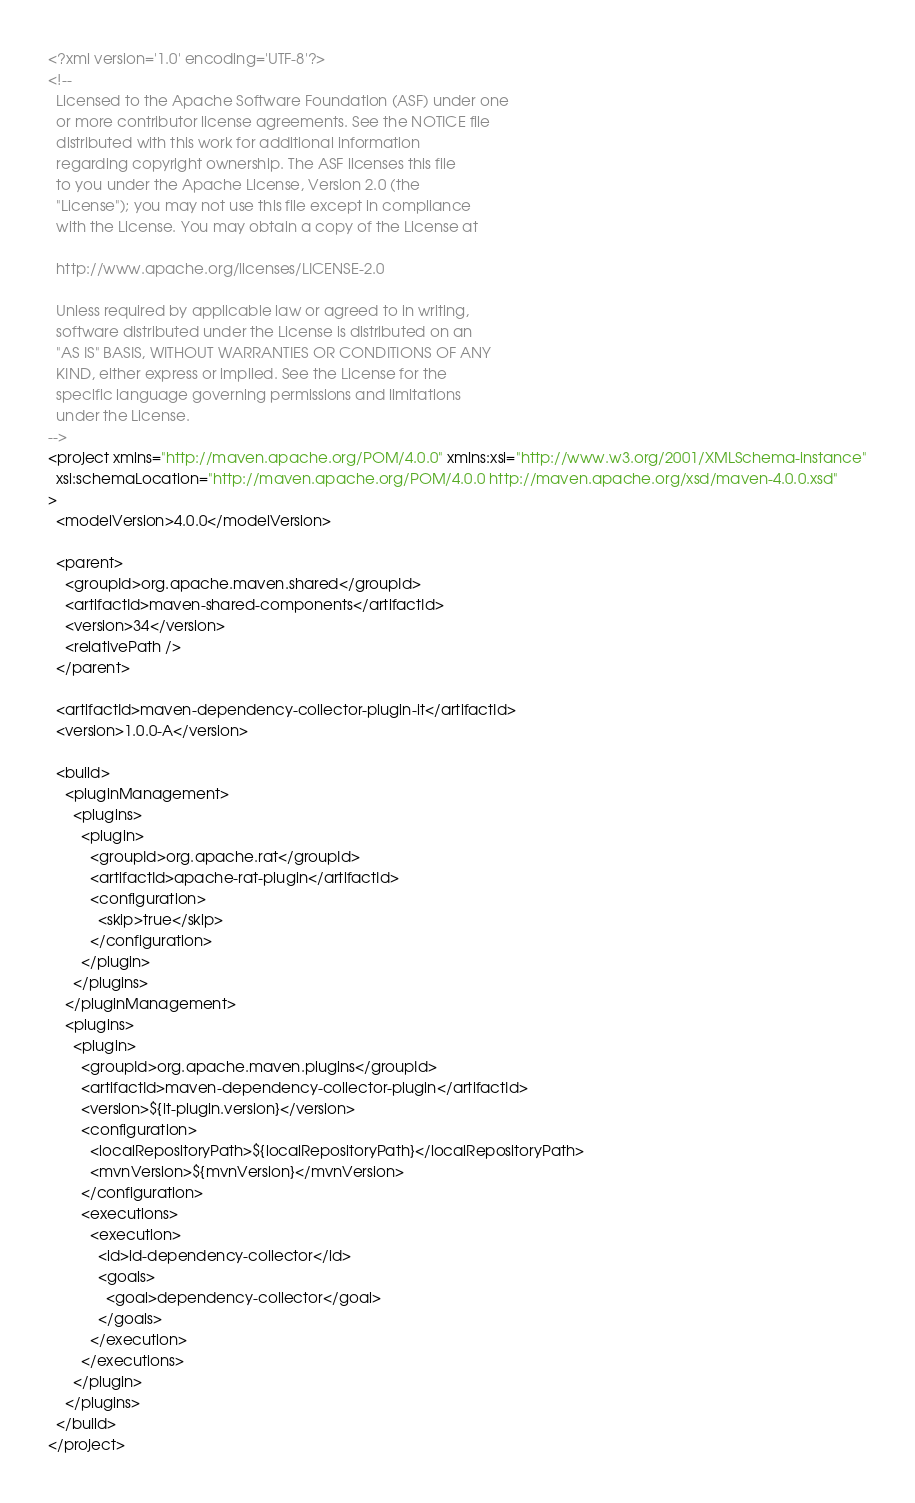Convert code to text. <code><loc_0><loc_0><loc_500><loc_500><_XML_><?xml version='1.0' encoding='UTF-8'?>
<!--
  Licensed to the Apache Software Foundation (ASF) under one
  or more contributor license agreements. See the NOTICE file
  distributed with this work for additional information
  regarding copyright ownership. The ASF licenses this file
  to you under the Apache License, Version 2.0 (the
  "License"); you may not use this file except in compliance
  with the License. You may obtain a copy of the License at

  http://www.apache.org/licenses/LICENSE-2.0

  Unless required by applicable law or agreed to in writing,
  software distributed under the License is distributed on an
  "AS IS" BASIS, WITHOUT WARRANTIES OR CONDITIONS OF ANY
  KIND, either express or implied. See the License for the
  specific language governing permissions and limitations
  under the License.
-->
<project xmlns="http://maven.apache.org/POM/4.0.0" xmlns:xsi="http://www.w3.org/2001/XMLSchema-instance"
  xsi:schemaLocation="http://maven.apache.org/POM/4.0.0 http://maven.apache.org/xsd/maven-4.0.0.xsd"
>
  <modelVersion>4.0.0</modelVersion>

  <parent>
    <groupId>org.apache.maven.shared</groupId>
    <artifactId>maven-shared-components</artifactId>
    <version>34</version>
    <relativePath />
  </parent>

  <artifactId>maven-dependency-collector-plugin-it</artifactId>
  <version>1.0.0-A</version>

  <build>
    <pluginManagement>
      <plugins>
        <plugin>
          <groupId>org.apache.rat</groupId>
          <artifactId>apache-rat-plugin</artifactId>
          <configuration>
            <skip>true</skip>
          </configuration>
        </plugin>
      </plugins>
    </pluginManagement>
    <plugins>
      <plugin>
        <groupId>org.apache.maven.plugins</groupId>
        <artifactId>maven-dependency-collector-plugin</artifactId>
        <version>${it-plugin.version}</version>
        <configuration>
          <localRepositoryPath>${localRepositoryPath}</localRepositoryPath>
          <mvnVersion>${mvnVersion}</mvnVersion>
        </configuration>
        <executions>
          <execution>
            <id>id-dependency-collector</id>
            <goals>
              <goal>dependency-collector</goal>
            </goals>
          </execution>
        </executions>
      </plugin>
    </plugins>
  </build>
</project>
</code> 